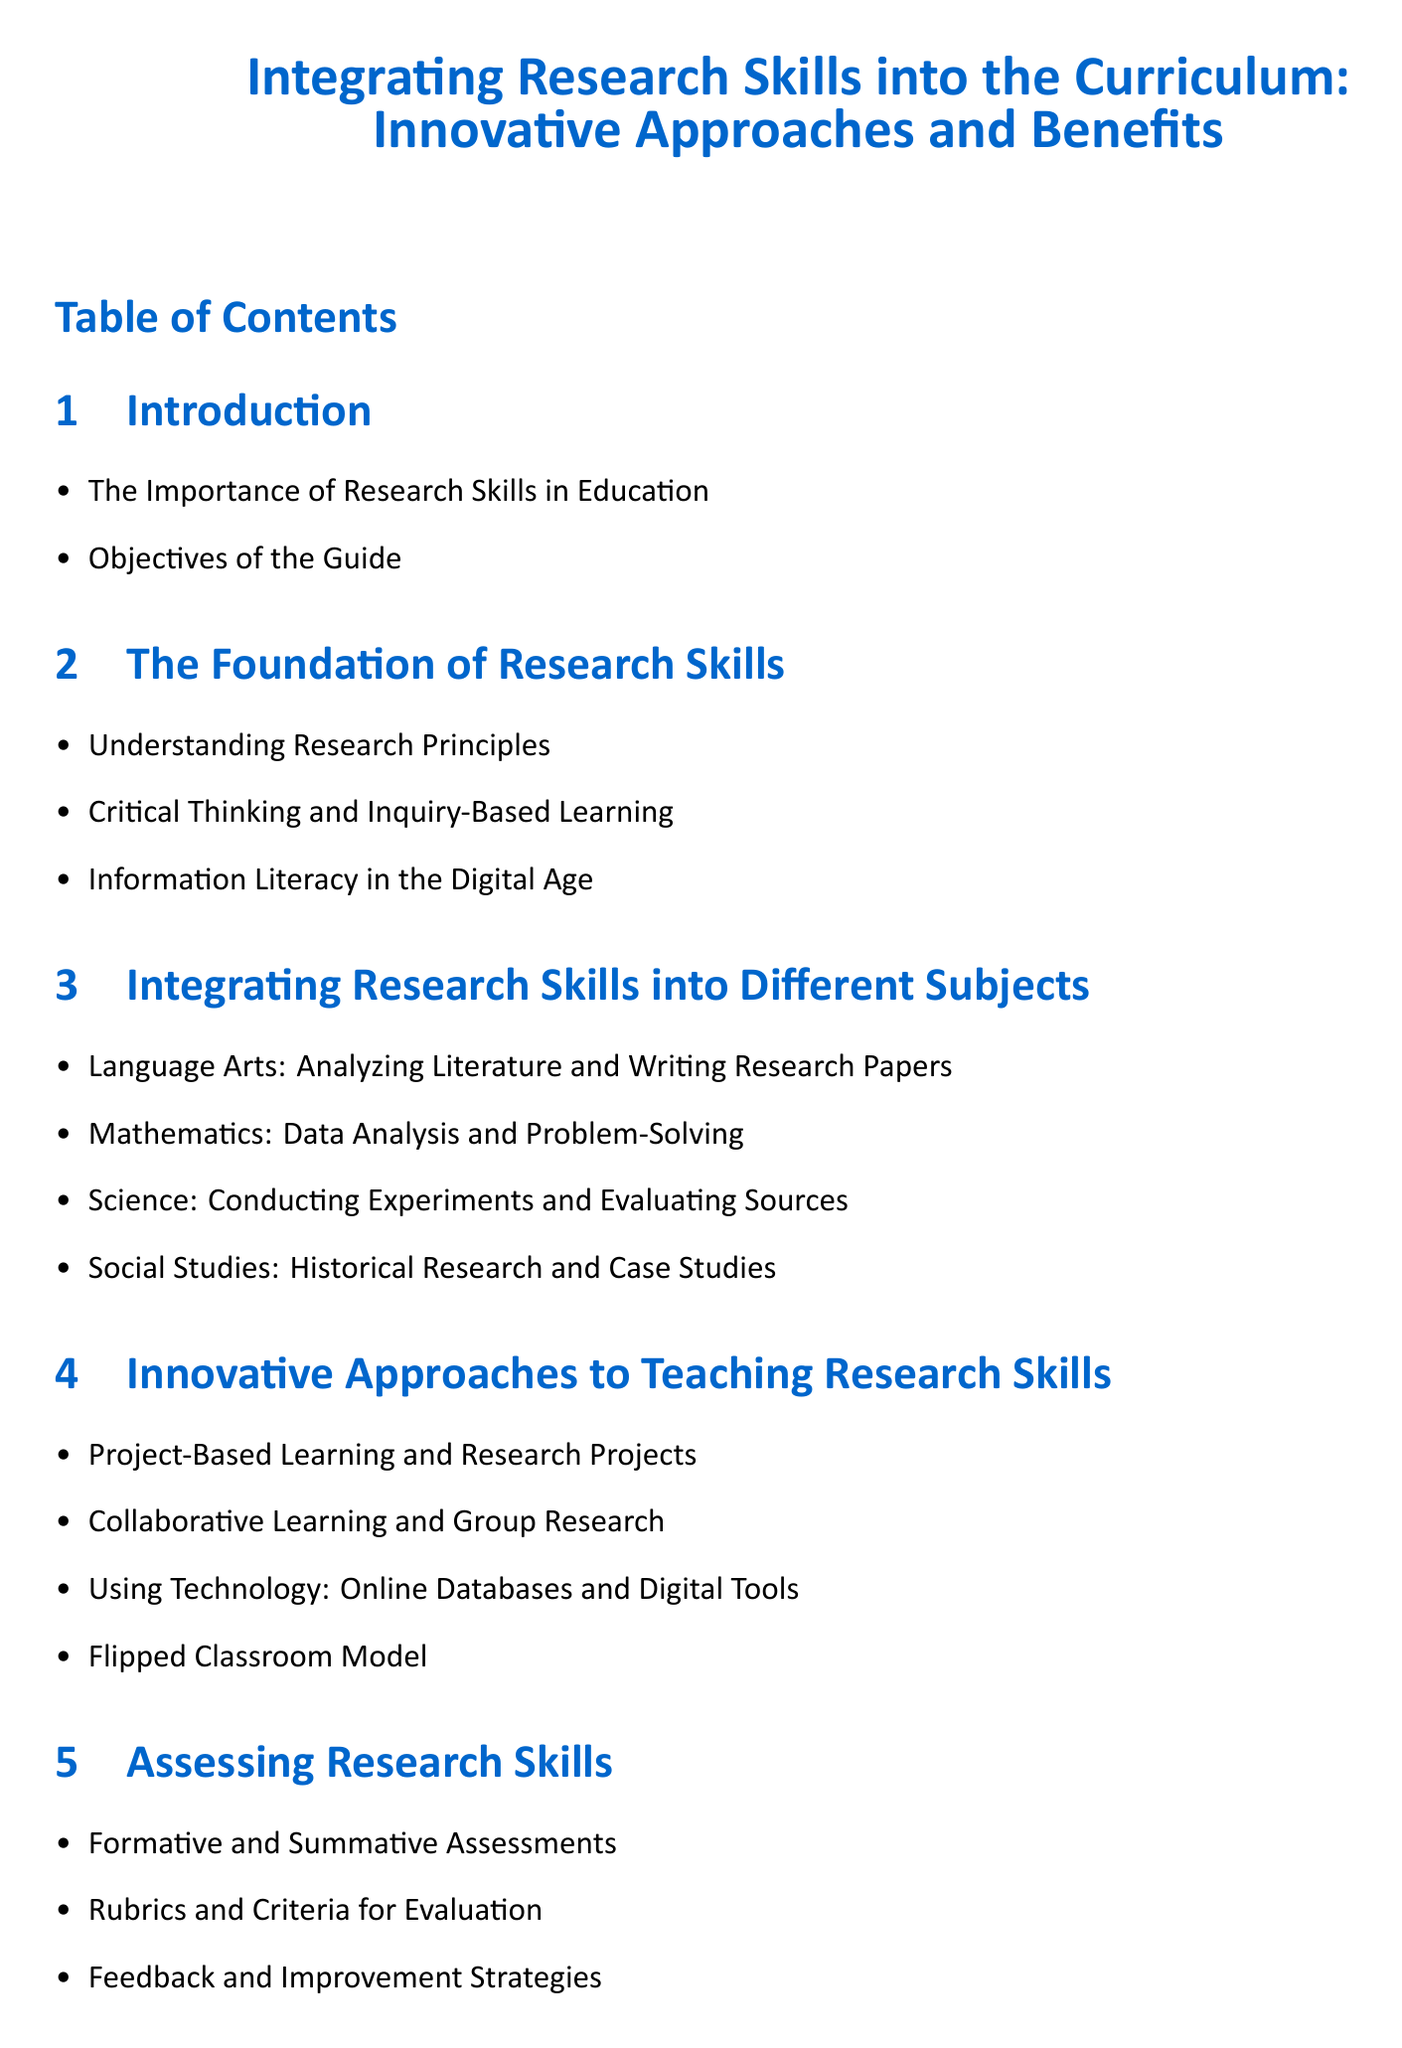What is the title of the document? The title of the document is the first line in the center of the rendered document.
Answer: Integrating Research Skills into the Curriculum: Innovative Approaches and Benefits What section comes after "Integrating Research Skills into Different Subjects"? Each section follows a specific order in the table of contents, and this requires understanding that order.
Answer: Innovative Approaches to Teaching Research Skills How many subsections are in “The Foundation of Research Skills”? The number of items listed under "The Foundation of Research Skills" indicates its subsections.
Answer: Three What approach is suggested for teaching research skills that involves students working together? This requires synthesizing information specifically from the “Innovative Approaches to Teaching Research Skills” section.
Answer: Collaborative Learning and Group Research Which skill is highlighted as essential in the digital age? The document outlines specific concepts within sections, and this information resides under “The Foundation of Research Skills.”
Answer: Information Literacy What are the two types of assessments mentioned in the document? By attempting to recall specific content under the “Assessing Research Skills” section, one can compile this information.
Answer: Formative and Summative Assessments How many benefits of integrating research skills are listed in the document? Counting the items in the "Benefits of Integrating Research Skills" gives this information.
Answer: Four What is the overall objective of the guide? This question refers to the first subsection of the introduction outlining the guide’s purpose.
Answer: Objectives of the Guide What learning model is included in the innovative teaching approaches? Analyzing the list of innovative approaches reveals which model is included.
Answer: Flipped Classroom Model What section summarizes key points and future directions in the document? The structure of the document indicates the final section, which provides summary content.
Answer: Conclusion 